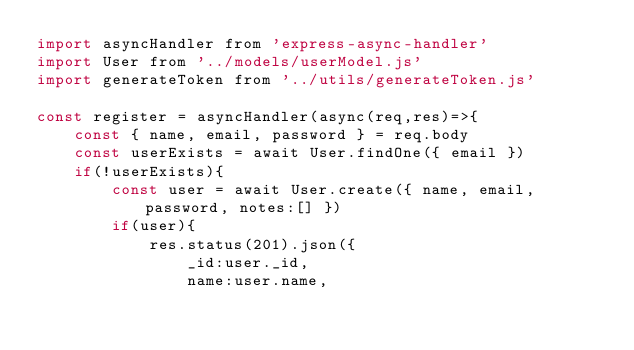<code> <loc_0><loc_0><loc_500><loc_500><_JavaScript_>import asyncHandler from 'express-async-handler'
import User from '../models/userModel.js'
import generateToken from '../utils/generateToken.js'

const register = asyncHandler(async(req,res)=>{
    const { name, email, password } = req.body
    const userExists = await User.findOne({ email })
    if(!userExists){
        const user = await User.create({ name, email, password, notes:[] })
        if(user){
            res.status(201).json({
                _id:user._id,
                name:user.name,</code> 